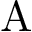<formula> <loc_0><loc_0><loc_500><loc_500>A</formula> 